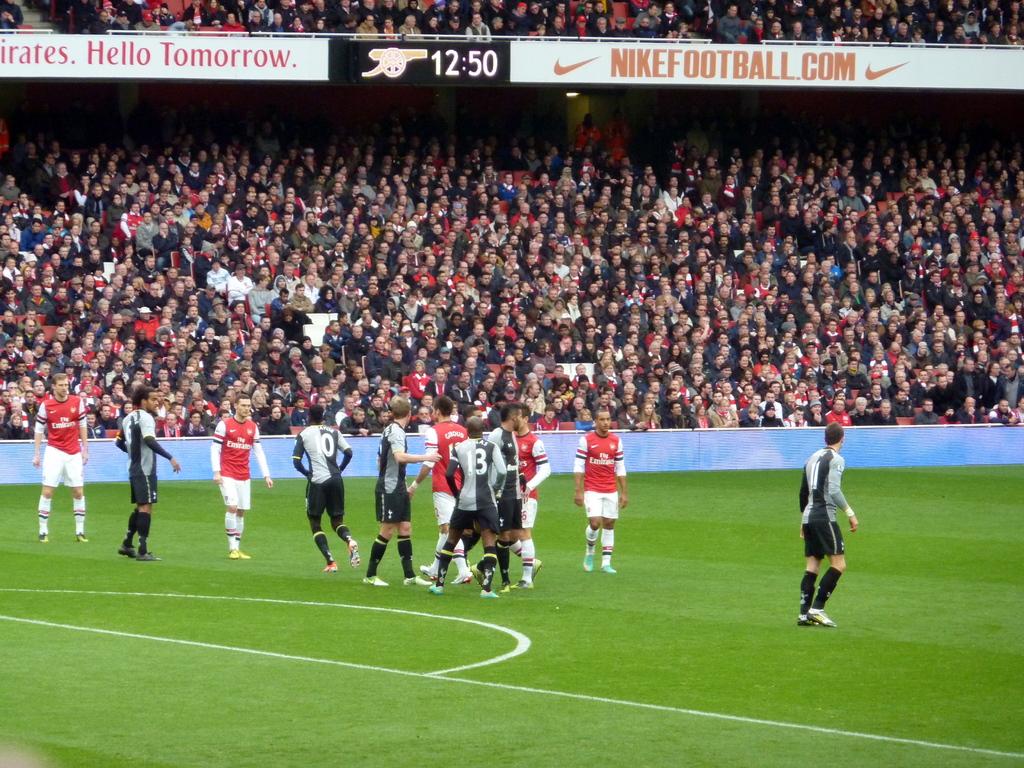What is the time on the clock?
Ensure brevity in your answer.  12:50. What website sponsored the field?
Your answer should be compact. Nikefootball.com. 